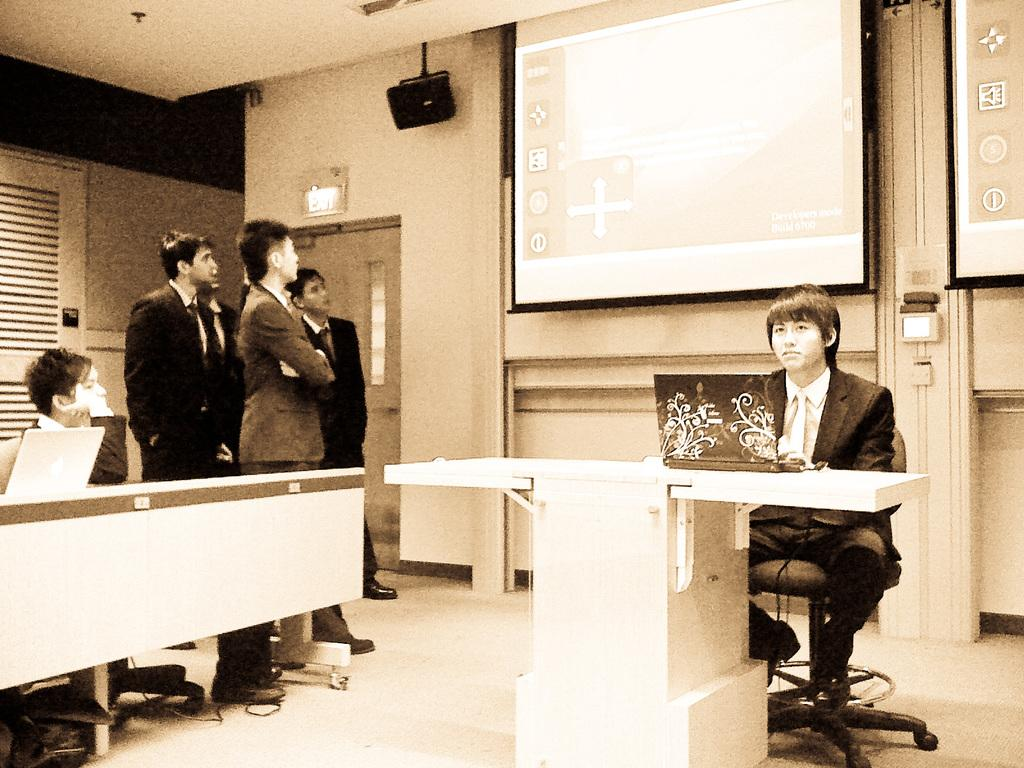What is the seated man doing in the image? There is a man seated on a chair in the image. What is in front of the seated man? There is a table in front of the seated man. What are the standing men doing in the image? The standing men are watching a projector screen. Can you describe the activity of the seated man with the laptop? There is a man seated with a laptop on the table. What type of gun is the man holding in the image? There is no gun present in the image. What reward is being offered for completing the task on the projector screen? There is no mention of a reward or task in the image. 